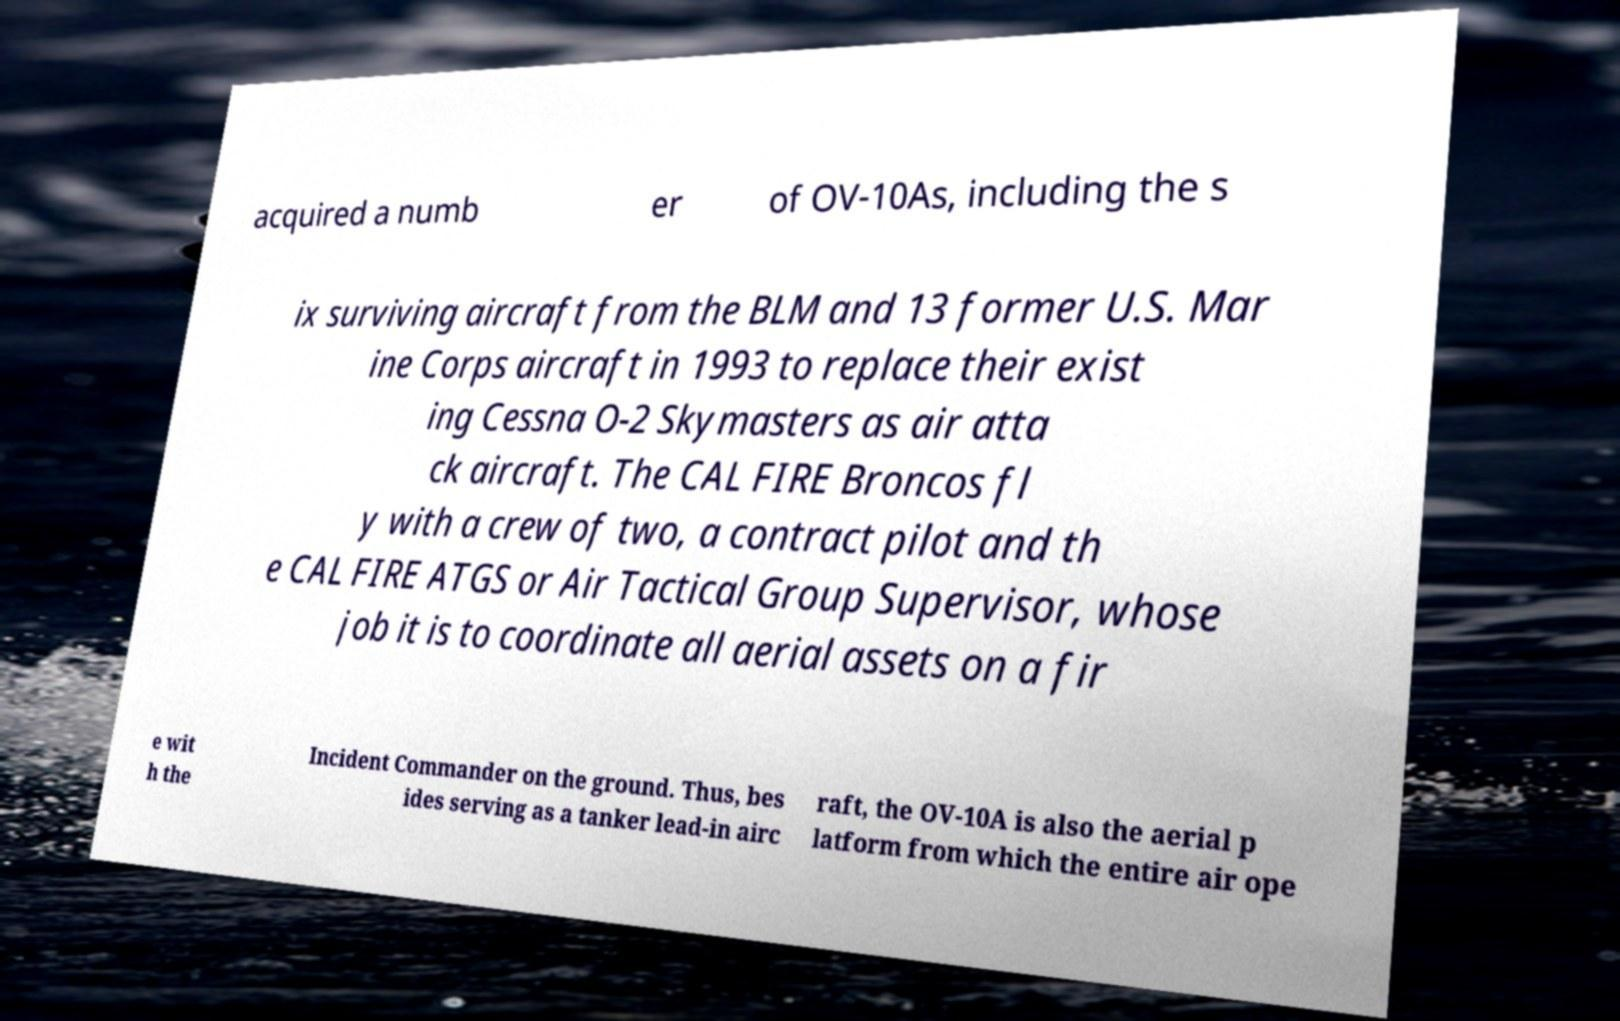There's text embedded in this image that I need extracted. Can you transcribe it verbatim? acquired a numb er of OV-10As, including the s ix surviving aircraft from the BLM and 13 former U.S. Mar ine Corps aircraft in 1993 to replace their exist ing Cessna O-2 Skymasters as air atta ck aircraft. The CAL FIRE Broncos fl y with a crew of two, a contract pilot and th e CAL FIRE ATGS or Air Tactical Group Supervisor, whose job it is to coordinate all aerial assets on a fir e wit h the Incident Commander on the ground. Thus, bes ides serving as a tanker lead-in airc raft, the OV-10A is also the aerial p latform from which the entire air ope 